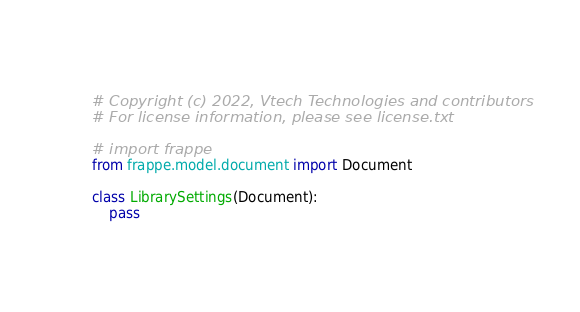Convert code to text. <code><loc_0><loc_0><loc_500><loc_500><_Python_># Copyright (c) 2022, Vtech Technologies and contributors
# For license information, please see license.txt

# import frappe
from frappe.model.document import Document

class LibrarySettings(Document):
	pass
</code> 